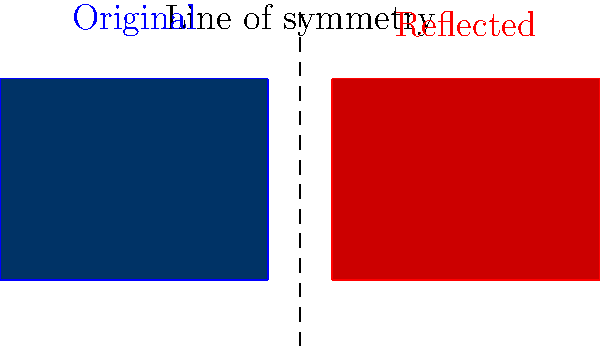In the image above, the blue rectangle represents the Houston Texans logo, and the red rectangle is its reflection across the dashed line. If the coordinates of point $C$ in the original logo are $(4,3)$, what are the coordinates of the corresponding point $G$ in the reflected logo? To find the coordinates of point $G$, we need to reflect point $C$ across the line of symmetry. Let's approach this step-by-step:

1) The line of symmetry is at $x = 4.5$, halfway between the two logos.

2) Point $C$ has coordinates $(4,3)$.

3) To reflect a point across a vertical line, we keep the $y$-coordinate the same and change the $x$-coordinate.

4) The distance from point $C$ to the line of symmetry is $4.5 - 4 = 0.5$.

5) The reflected point will be the same distance from the line of symmetry on the other side.

6) So, the $x$-coordinate of point $G$ will be $4.5 + 0.5 = 5$.

7) The $y$-coordinate remains unchanged at $3$.

Therefore, the coordinates of point $G$ are $(5,3)$.
Answer: $(5,3)$ 